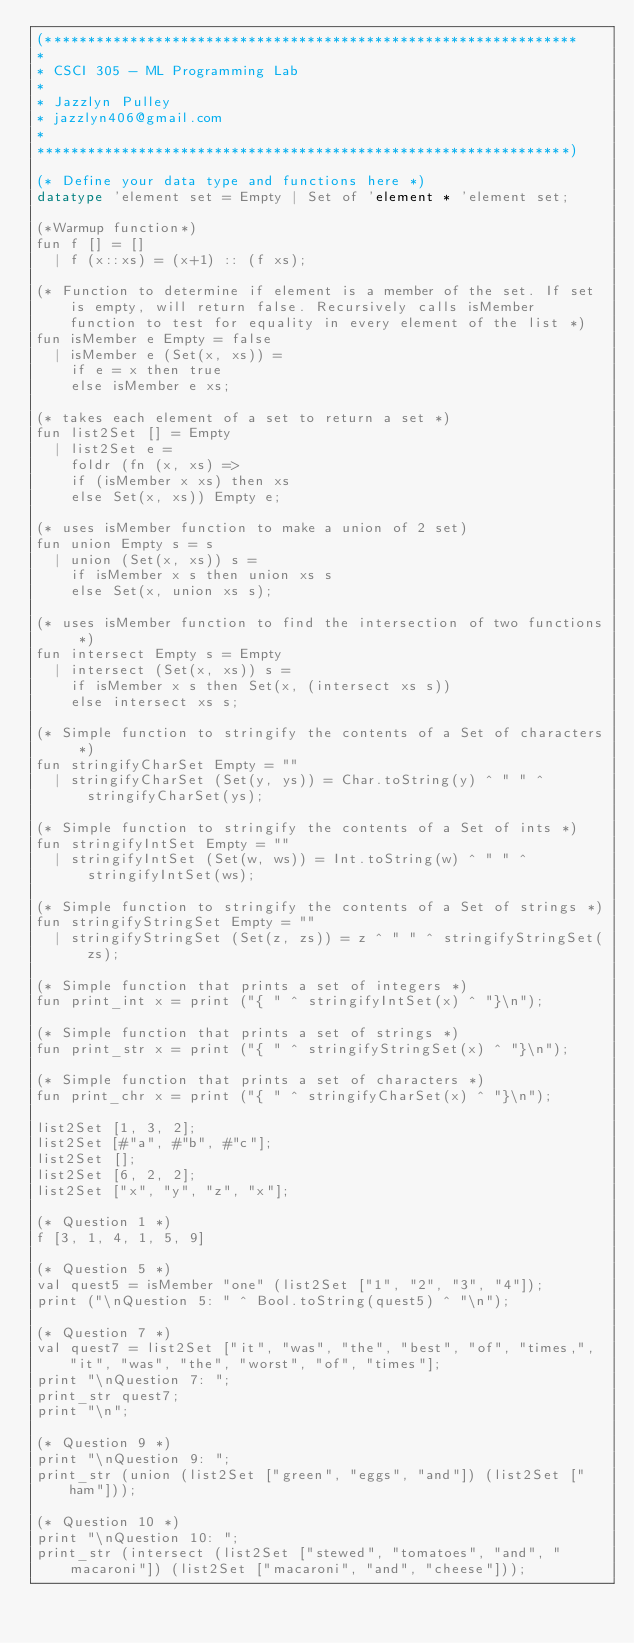Convert code to text. <code><loc_0><loc_0><loc_500><loc_500><_SML_>(***************************************************************
*
* CSCI 305 - ML Programming Lab
*
* Jazzlyn Pulley
* jazzlyn406@gmail.com
*
***************************************************************)

(* Define your data type and functions here *)
datatype 'element set = Empty | Set of 'element * 'element set;

(*Warmup function*)
fun f [] = []
  | f (x::xs) = (x+1) :: (f xs);

(* Function to determine if element is a member of the set. If set is empty, will return false. Recursively calls isMember function to test for equality in every element of the list *)
fun isMember e Empty = false
  | isMember e (Set(x, xs)) =
    if e = x then true
    else isMember e xs;

(* takes each element of a set to return a set *)
fun list2Set [] = Empty
  | list2Set e =
    foldr (fn (x, xs) =>
    if (isMember x xs) then xs
    else Set(x, xs)) Empty e;

(* uses isMember function to make a union of 2 set)
fun union Empty s = s
  | union (Set(x, xs)) s =
    if isMember x s then union xs s
    else Set(x, union xs s);

(* uses isMember function to find the intersection of two functions *)
fun intersect Empty s = Empty
  | intersect (Set(x, xs)) s =
    if isMember x s then Set(x, (intersect xs s))
    else intersect xs s;

(* Simple function to stringify the contents of a Set of characters *)
fun stringifyCharSet Empty = ""
  | stringifyCharSet (Set(y, ys)) = Char.toString(y) ^ " " ^ stringifyCharSet(ys);

(* Simple function to stringify the contents of a Set of ints *)
fun stringifyIntSet Empty = ""
  | stringifyIntSet (Set(w, ws)) = Int.toString(w) ^ " " ^ stringifyIntSet(ws);

(* Simple function to stringify the contents of a Set of strings *)
fun stringifyStringSet Empty = ""
  | stringifyStringSet (Set(z, zs)) = z ^ " " ^ stringifyStringSet(zs);

(* Simple function that prints a set of integers *)
fun print_int x = print ("{ " ^ stringifyIntSet(x) ^ "}\n");

(* Simple function that prints a set of strings *)
fun print_str x = print ("{ " ^ stringifyStringSet(x) ^ "}\n");

(* Simple function that prints a set of characters *)
fun print_chr x = print ("{ " ^ stringifyCharSet(x) ^ "}\n");

list2Set [1, 3, 2];
list2Set [#"a", #"b", #"c"];
list2Set [];
list2Set [6, 2, 2];
list2Set ["x", "y", "z", "x"];

(* Question 1 *)
f [3, 1, 4, 1, 5, 9]

(* Question 5 *)
val quest5 = isMember "one" (list2Set ["1", "2", "3", "4"]);
print ("\nQuestion 5: " ^ Bool.toString(quest5) ^ "\n");

(* Question 7 *)
val quest7 = list2Set ["it", "was", "the", "best", "of", "times,", "it", "was", "the", "worst", "of", "times"];
print "\nQuestion 7: ";
print_str quest7;
print "\n";

(* Question 9 *)
print "\nQuestion 9: ";
print_str (union (list2Set ["green", "eggs", "and"]) (list2Set ["ham"]));

(* Question 10 *)
print "\nQuestion 10: ";
print_str (intersect (list2Set ["stewed", "tomatoes", "and", "macaroni"]) (list2Set ["macaroni", "and", "cheese"])); 
</code> 